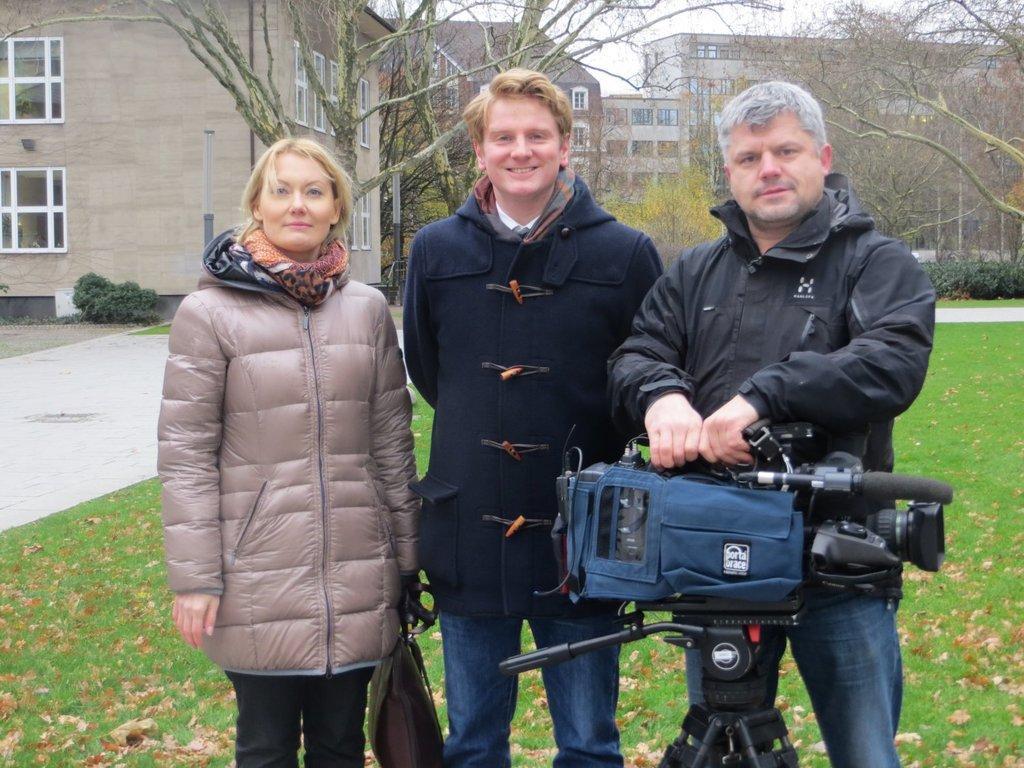Could you give a brief overview of what you see in this image? In this picture there are people standing, among them there's a man holding a camera and there is a woman holding a bag and we can see grass, leaves and stand. In the background of the image we can see trees, plants, buildings and sky. 